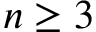<formula> <loc_0><loc_0><loc_500><loc_500>n \geq 3</formula> 